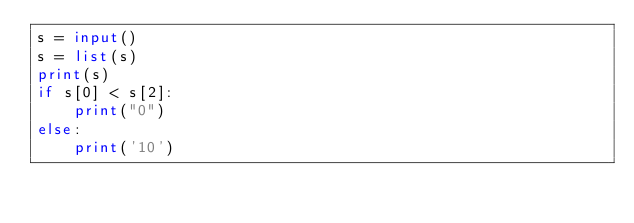<code> <loc_0><loc_0><loc_500><loc_500><_Python_>s = input()
s = list(s)
print(s)
if s[0] < s[2]:
    print("0")
else:
    print('10')</code> 